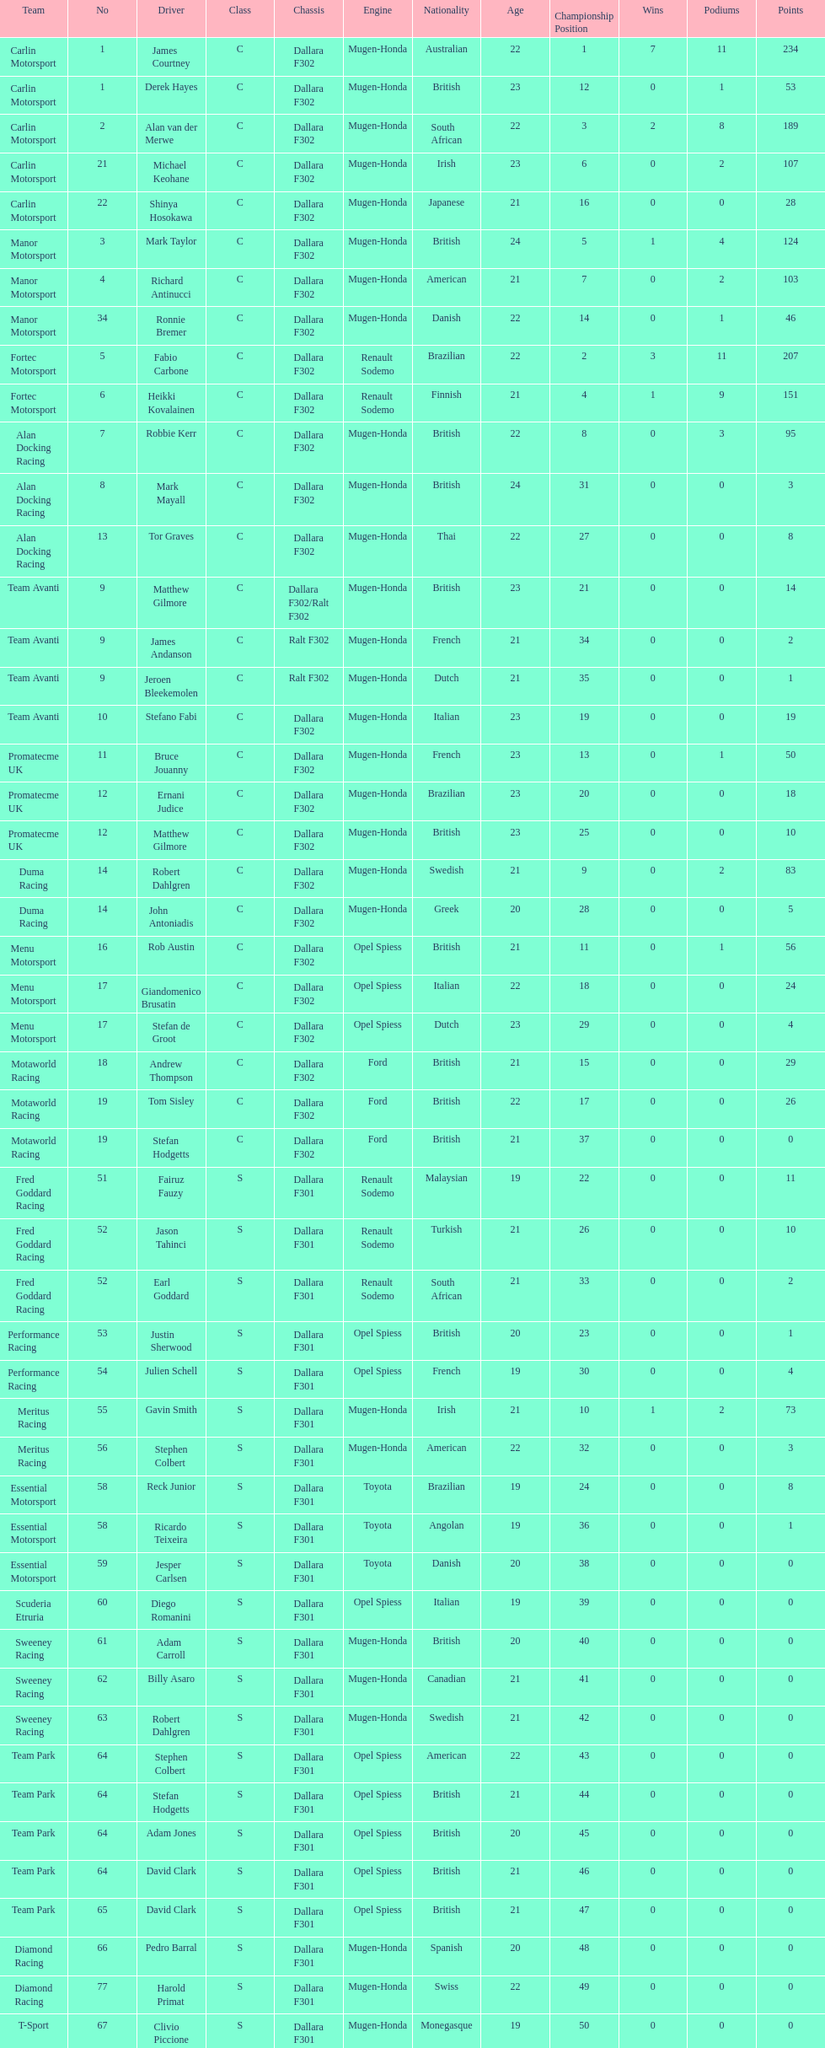What is the average number of teams that had a mugen-honda engine? 24. 